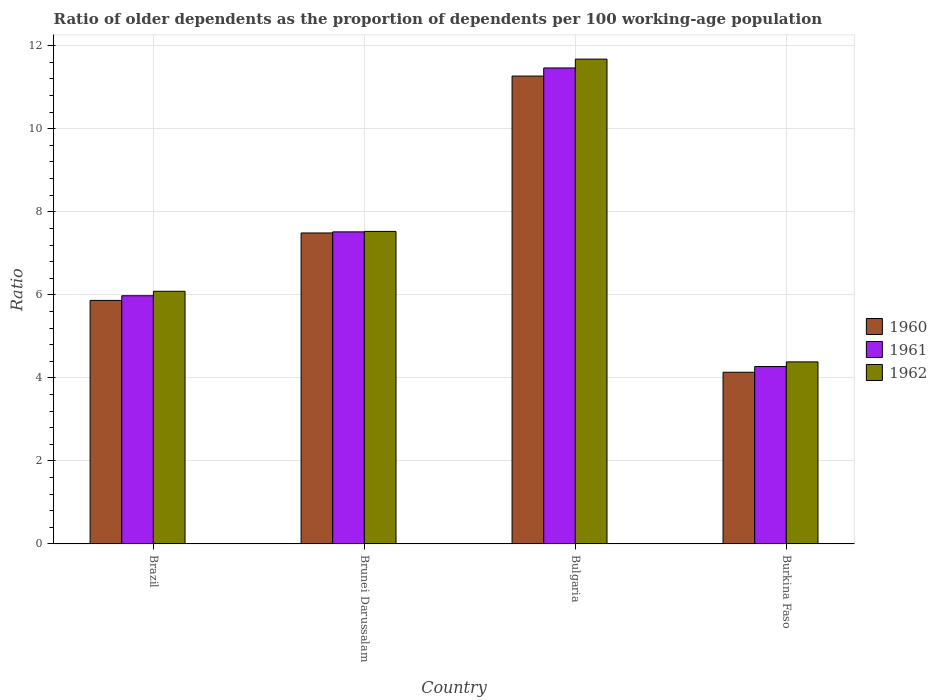Are the number of bars per tick equal to the number of legend labels?
Keep it short and to the point. Yes. How many bars are there on the 1st tick from the left?
Your answer should be compact. 3. How many bars are there on the 2nd tick from the right?
Give a very brief answer. 3. What is the age dependency ratio(old) in 1961 in Brazil?
Your answer should be compact. 5.98. Across all countries, what is the maximum age dependency ratio(old) in 1960?
Offer a terse response. 11.27. Across all countries, what is the minimum age dependency ratio(old) in 1961?
Provide a short and direct response. 4.27. In which country was the age dependency ratio(old) in 1960 maximum?
Provide a short and direct response. Bulgaria. In which country was the age dependency ratio(old) in 1960 minimum?
Make the answer very short. Burkina Faso. What is the total age dependency ratio(old) in 1962 in the graph?
Provide a short and direct response. 29.68. What is the difference between the age dependency ratio(old) in 1960 in Brazil and that in Bulgaria?
Ensure brevity in your answer.  -5.4. What is the difference between the age dependency ratio(old) in 1960 in Brunei Darussalam and the age dependency ratio(old) in 1961 in Bulgaria?
Your answer should be compact. -3.97. What is the average age dependency ratio(old) in 1962 per country?
Offer a terse response. 7.42. What is the difference between the age dependency ratio(old) of/in 1961 and age dependency ratio(old) of/in 1960 in Burkina Faso?
Provide a short and direct response. 0.14. What is the ratio of the age dependency ratio(old) in 1960 in Brazil to that in Burkina Faso?
Give a very brief answer. 1.42. Is the age dependency ratio(old) in 1960 in Brazil less than that in Brunei Darussalam?
Ensure brevity in your answer.  Yes. What is the difference between the highest and the second highest age dependency ratio(old) in 1960?
Provide a succinct answer. 5.4. What is the difference between the highest and the lowest age dependency ratio(old) in 1962?
Your answer should be compact. 7.29. In how many countries, is the age dependency ratio(old) in 1960 greater than the average age dependency ratio(old) in 1960 taken over all countries?
Your answer should be compact. 2. Is the sum of the age dependency ratio(old) in 1962 in Brazil and Brunei Darussalam greater than the maximum age dependency ratio(old) in 1960 across all countries?
Your answer should be very brief. Yes. What does the 3rd bar from the left in Brazil represents?
Offer a terse response. 1962. How many bars are there?
Offer a very short reply. 12. Are all the bars in the graph horizontal?
Make the answer very short. No. How many countries are there in the graph?
Offer a terse response. 4. Does the graph contain any zero values?
Keep it short and to the point. No. Does the graph contain grids?
Keep it short and to the point. Yes. Where does the legend appear in the graph?
Give a very brief answer. Center right. How many legend labels are there?
Make the answer very short. 3. How are the legend labels stacked?
Provide a short and direct response. Vertical. What is the title of the graph?
Your response must be concise. Ratio of older dependents as the proportion of dependents per 100 working-age population. Does "1960" appear as one of the legend labels in the graph?
Give a very brief answer. Yes. What is the label or title of the X-axis?
Ensure brevity in your answer.  Country. What is the label or title of the Y-axis?
Your answer should be compact. Ratio. What is the Ratio of 1960 in Brazil?
Provide a short and direct response. 5.87. What is the Ratio of 1961 in Brazil?
Offer a terse response. 5.98. What is the Ratio of 1962 in Brazil?
Your answer should be compact. 6.09. What is the Ratio of 1960 in Brunei Darussalam?
Provide a short and direct response. 7.49. What is the Ratio of 1961 in Brunei Darussalam?
Give a very brief answer. 7.52. What is the Ratio in 1962 in Brunei Darussalam?
Ensure brevity in your answer.  7.53. What is the Ratio in 1960 in Bulgaria?
Your answer should be compact. 11.27. What is the Ratio of 1961 in Bulgaria?
Give a very brief answer. 11.46. What is the Ratio in 1962 in Bulgaria?
Your answer should be compact. 11.68. What is the Ratio of 1960 in Burkina Faso?
Your answer should be very brief. 4.14. What is the Ratio in 1961 in Burkina Faso?
Provide a short and direct response. 4.27. What is the Ratio in 1962 in Burkina Faso?
Ensure brevity in your answer.  4.39. Across all countries, what is the maximum Ratio of 1960?
Give a very brief answer. 11.27. Across all countries, what is the maximum Ratio of 1961?
Keep it short and to the point. 11.46. Across all countries, what is the maximum Ratio in 1962?
Keep it short and to the point. 11.68. Across all countries, what is the minimum Ratio of 1960?
Make the answer very short. 4.14. Across all countries, what is the minimum Ratio in 1961?
Your answer should be compact. 4.27. Across all countries, what is the minimum Ratio of 1962?
Offer a terse response. 4.39. What is the total Ratio in 1960 in the graph?
Provide a succinct answer. 28.76. What is the total Ratio in 1961 in the graph?
Give a very brief answer. 29.23. What is the total Ratio in 1962 in the graph?
Your answer should be very brief. 29.68. What is the difference between the Ratio of 1960 in Brazil and that in Brunei Darussalam?
Your answer should be compact. -1.62. What is the difference between the Ratio in 1961 in Brazil and that in Brunei Darussalam?
Make the answer very short. -1.54. What is the difference between the Ratio of 1962 in Brazil and that in Brunei Darussalam?
Your answer should be compact. -1.44. What is the difference between the Ratio in 1960 in Brazil and that in Bulgaria?
Make the answer very short. -5.4. What is the difference between the Ratio of 1961 in Brazil and that in Bulgaria?
Make the answer very short. -5.49. What is the difference between the Ratio in 1962 in Brazil and that in Bulgaria?
Your response must be concise. -5.59. What is the difference between the Ratio in 1960 in Brazil and that in Burkina Faso?
Your answer should be compact. 1.73. What is the difference between the Ratio in 1961 in Brazil and that in Burkina Faso?
Your answer should be very brief. 1.71. What is the difference between the Ratio in 1962 in Brazil and that in Burkina Faso?
Your response must be concise. 1.7. What is the difference between the Ratio in 1960 in Brunei Darussalam and that in Bulgaria?
Provide a succinct answer. -3.78. What is the difference between the Ratio in 1961 in Brunei Darussalam and that in Bulgaria?
Offer a very short reply. -3.95. What is the difference between the Ratio in 1962 in Brunei Darussalam and that in Bulgaria?
Give a very brief answer. -4.15. What is the difference between the Ratio of 1960 in Brunei Darussalam and that in Burkina Faso?
Your response must be concise. 3.35. What is the difference between the Ratio of 1961 in Brunei Darussalam and that in Burkina Faso?
Keep it short and to the point. 3.24. What is the difference between the Ratio in 1962 in Brunei Darussalam and that in Burkina Faso?
Keep it short and to the point. 3.14. What is the difference between the Ratio in 1960 in Bulgaria and that in Burkina Faso?
Your answer should be compact. 7.13. What is the difference between the Ratio in 1961 in Bulgaria and that in Burkina Faso?
Give a very brief answer. 7.19. What is the difference between the Ratio of 1962 in Bulgaria and that in Burkina Faso?
Your response must be concise. 7.29. What is the difference between the Ratio of 1960 in Brazil and the Ratio of 1961 in Brunei Darussalam?
Your response must be concise. -1.65. What is the difference between the Ratio of 1960 in Brazil and the Ratio of 1962 in Brunei Darussalam?
Your answer should be compact. -1.66. What is the difference between the Ratio of 1961 in Brazil and the Ratio of 1962 in Brunei Darussalam?
Keep it short and to the point. -1.55. What is the difference between the Ratio in 1960 in Brazil and the Ratio in 1961 in Bulgaria?
Provide a short and direct response. -5.6. What is the difference between the Ratio of 1960 in Brazil and the Ratio of 1962 in Bulgaria?
Your answer should be very brief. -5.81. What is the difference between the Ratio in 1961 in Brazil and the Ratio in 1962 in Bulgaria?
Your response must be concise. -5.7. What is the difference between the Ratio of 1960 in Brazil and the Ratio of 1961 in Burkina Faso?
Give a very brief answer. 1.59. What is the difference between the Ratio of 1960 in Brazil and the Ratio of 1962 in Burkina Faso?
Provide a short and direct response. 1.48. What is the difference between the Ratio in 1961 in Brazil and the Ratio in 1962 in Burkina Faso?
Provide a succinct answer. 1.59. What is the difference between the Ratio in 1960 in Brunei Darussalam and the Ratio in 1961 in Bulgaria?
Your answer should be compact. -3.97. What is the difference between the Ratio of 1960 in Brunei Darussalam and the Ratio of 1962 in Bulgaria?
Your answer should be very brief. -4.19. What is the difference between the Ratio in 1961 in Brunei Darussalam and the Ratio in 1962 in Bulgaria?
Your answer should be very brief. -4.16. What is the difference between the Ratio of 1960 in Brunei Darussalam and the Ratio of 1961 in Burkina Faso?
Ensure brevity in your answer.  3.22. What is the difference between the Ratio of 1960 in Brunei Darussalam and the Ratio of 1962 in Burkina Faso?
Provide a succinct answer. 3.1. What is the difference between the Ratio in 1961 in Brunei Darussalam and the Ratio in 1962 in Burkina Faso?
Provide a short and direct response. 3.13. What is the difference between the Ratio in 1960 in Bulgaria and the Ratio in 1961 in Burkina Faso?
Provide a short and direct response. 7. What is the difference between the Ratio in 1960 in Bulgaria and the Ratio in 1962 in Burkina Faso?
Give a very brief answer. 6.88. What is the difference between the Ratio in 1961 in Bulgaria and the Ratio in 1962 in Burkina Faso?
Keep it short and to the point. 7.08. What is the average Ratio of 1960 per country?
Offer a very short reply. 7.19. What is the average Ratio of 1961 per country?
Give a very brief answer. 7.31. What is the average Ratio of 1962 per country?
Provide a short and direct response. 7.42. What is the difference between the Ratio in 1960 and Ratio in 1961 in Brazil?
Offer a terse response. -0.11. What is the difference between the Ratio of 1960 and Ratio of 1962 in Brazil?
Your response must be concise. -0.22. What is the difference between the Ratio in 1961 and Ratio in 1962 in Brazil?
Your answer should be compact. -0.11. What is the difference between the Ratio in 1960 and Ratio in 1961 in Brunei Darussalam?
Offer a very short reply. -0.03. What is the difference between the Ratio in 1960 and Ratio in 1962 in Brunei Darussalam?
Your response must be concise. -0.04. What is the difference between the Ratio of 1961 and Ratio of 1962 in Brunei Darussalam?
Ensure brevity in your answer.  -0.01. What is the difference between the Ratio in 1960 and Ratio in 1961 in Bulgaria?
Keep it short and to the point. -0.2. What is the difference between the Ratio in 1960 and Ratio in 1962 in Bulgaria?
Your response must be concise. -0.41. What is the difference between the Ratio in 1961 and Ratio in 1962 in Bulgaria?
Provide a short and direct response. -0.21. What is the difference between the Ratio of 1960 and Ratio of 1961 in Burkina Faso?
Give a very brief answer. -0.14. What is the difference between the Ratio in 1960 and Ratio in 1962 in Burkina Faso?
Your answer should be compact. -0.25. What is the difference between the Ratio of 1961 and Ratio of 1962 in Burkina Faso?
Your answer should be very brief. -0.11. What is the ratio of the Ratio of 1960 in Brazil to that in Brunei Darussalam?
Make the answer very short. 0.78. What is the ratio of the Ratio of 1961 in Brazil to that in Brunei Darussalam?
Ensure brevity in your answer.  0.8. What is the ratio of the Ratio in 1962 in Brazil to that in Brunei Darussalam?
Provide a succinct answer. 0.81. What is the ratio of the Ratio of 1960 in Brazil to that in Bulgaria?
Ensure brevity in your answer.  0.52. What is the ratio of the Ratio in 1961 in Brazil to that in Bulgaria?
Make the answer very short. 0.52. What is the ratio of the Ratio of 1962 in Brazil to that in Bulgaria?
Your response must be concise. 0.52. What is the ratio of the Ratio of 1960 in Brazil to that in Burkina Faso?
Offer a very short reply. 1.42. What is the ratio of the Ratio in 1961 in Brazil to that in Burkina Faso?
Provide a succinct answer. 1.4. What is the ratio of the Ratio in 1962 in Brazil to that in Burkina Faso?
Offer a very short reply. 1.39. What is the ratio of the Ratio of 1960 in Brunei Darussalam to that in Bulgaria?
Your answer should be very brief. 0.66. What is the ratio of the Ratio in 1961 in Brunei Darussalam to that in Bulgaria?
Offer a very short reply. 0.66. What is the ratio of the Ratio in 1962 in Brunei Darussalam to that in Bulgaria?
Keep it short and to the point. 0.64. What is the ratio of the Ratio of 1960 in Brunei Darussalam to that in Burkina Faso?
Your response must be concise. 1.81. What is the ratio of the Ratio in 1961 in Brunei Darussalam to that in Burkina Faso?
Your answer should be compact. 1.76. What is the ratio of the Ratio of 1962 in Brunei Darussalam to that in Burkina Faso?
Provide a short and direct response. 1.72. What is the ratio of the Ratio of 1960 in Bulgaria to that in Burkina Faso?
Offer a terse response. 2.72. What is the ratio of the Ratio of 1961 in Bulgaria to that in Burkina Faso?
Offer a terse response. 2.68. What is the ratio of the Ratio in 1962 in Bulgaria to that in Burkina Faso?
Ensure brevity in your answer.  2.66. What is the difference between the highest and the second highest Ratio of 1960?
Your answer should be compact. 3.78. What is the difference between the highest and the second highest Ratio of 1961?
Your response must be concise. 3.95. What is the difference between the highest and the second highest Ratio of 1962?
Your answer should be very brief. 4.15. What is the difference between the highest and the lowest Ratio of 1960?
Offer a very short reply. 7.13. What is the difference between the highest and the lowest Ratio of 1961?
Provide a short and direct response. 7.19. What is the difference between the highest and the lowest Ratio of 1962?
Ensure brevity in your answer.  7.29. 